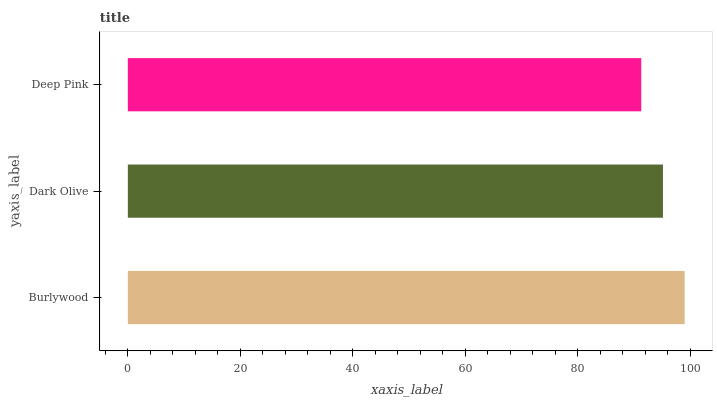Is Deep Pink the minimum?
Answer yes or no. Yes. Is Burlywood the maximum?
Answer yes or no. Yes. Is Dark Olive the minimum?
Answer yes or no. No. Is Dark Olive the maximum?
Answer yes or no. No. Is Burlywood greater than Dark Olive?
Answer yes or no. Yes. Is Dark Olive less than Burlywood?
Answer yes or no. Yes. Is Dark Olive greater than Burlywood?
Answer yes or no. No. Is Burlywood less than Dark Olive?
Answer yes or no. No. Is Dark Olive the high median?
Answer yes or no. Yes. Is Dark Olive the low median?
Answer yes or no. Yes. Is Burlywood the high median?
Answer yes or no. No. Is Burlywood the low median?
Answer yes or no. No. 